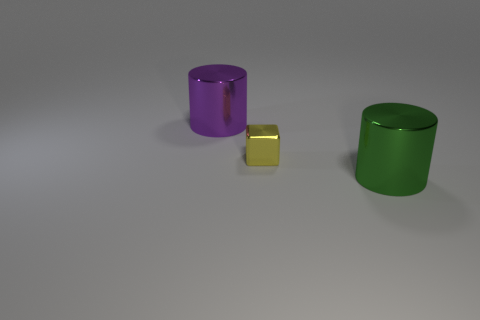Is there anything else that is the same size as the yellow object?
Provide a short and direct response. No. There is another cylinder that is the same size as the purple shiny cylinder; what color is it?
Keep it short and to the point. Green. How many other things are the same shape as the green thing?
Keep it short and to the point. 1. Do the green cylinder and the yellow cube have the same size?
Provide a short and direct response. No. Are there more large purple cylinders right of the green metal thing than purple metallic cylinders in front of the tiny yellow metallic cube?
Your answer should be very brief. No. How many other objects are there of the same size as the green metallic cylinder?
Make the answer very short. 1. Is the color of the object that is to the left of the tiny yellow block the same as the metallic cube?
Your answer should be very brief. No. Are there more large purple objects in front of the large green metal cylinder than big purple objects?
Provide a short and direct response. No. Is there anything else that has the same color as the small thing?
Give a very brief answer. No. What shape is the big shiny thing right of the metallic cylinder that is behind the green cylinder?
Provide a short and direct response. Cylinder. 